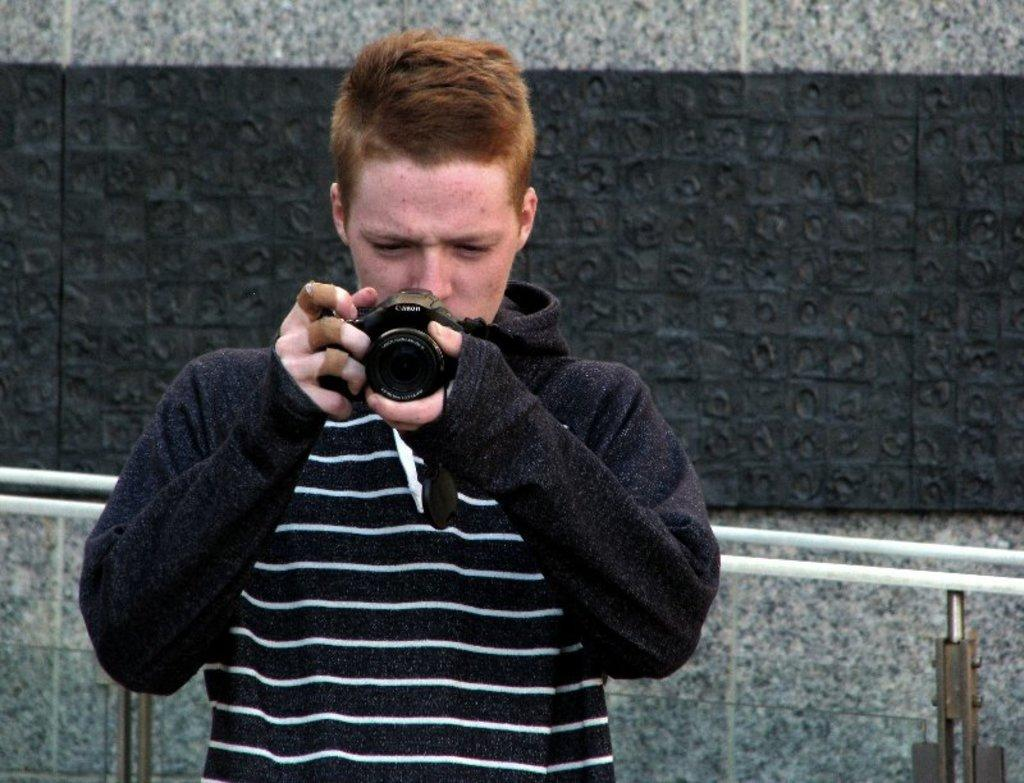Who is the main subject in the picture? There is a man in the picture. What is the man holding in his hand? The man is holding a camera in his hand. Can you describe the man's clothing? The man is wearing a black, full-length sleeves shirt. What can be seen in the background of the picture? There is a wall in the background of the picture. Where is the bed located in the image? There is no bed present in the image. Can you describe the lift that the man is using in the image? There is no lift present in the image; the man is holding a camera in his hand. 